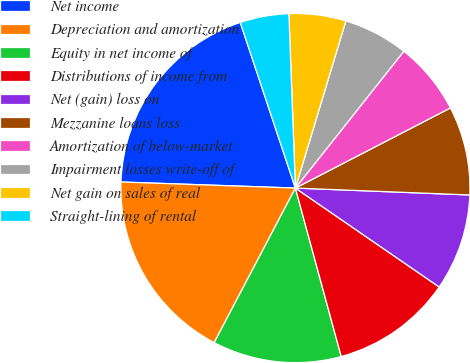Convert chart. <chart><loc_0><loc_0><loc_500><loc_500><pie_chart><fcel>Net income<fcel>Depreciation and amortization<fcel>Equity in net income of<fcel>Distributions of income from<fcel>Net (gain) loss on<fcel>Mezzanine loans loss<fcel>Amortization of below-market<fcel>Impairment losses write-off of<fcel>Net gain on sales of real<fcel>Straight-lining of rental<nl><fcel>19.33%<fcel>17.85%<fcel>11.93%<fcel>11.18%<fcel>8.96%<fcel>8.22%<fcel>6.74%<fcel>6.0%<fcel>5.26%<fcel>4.52%<nl></chart> 